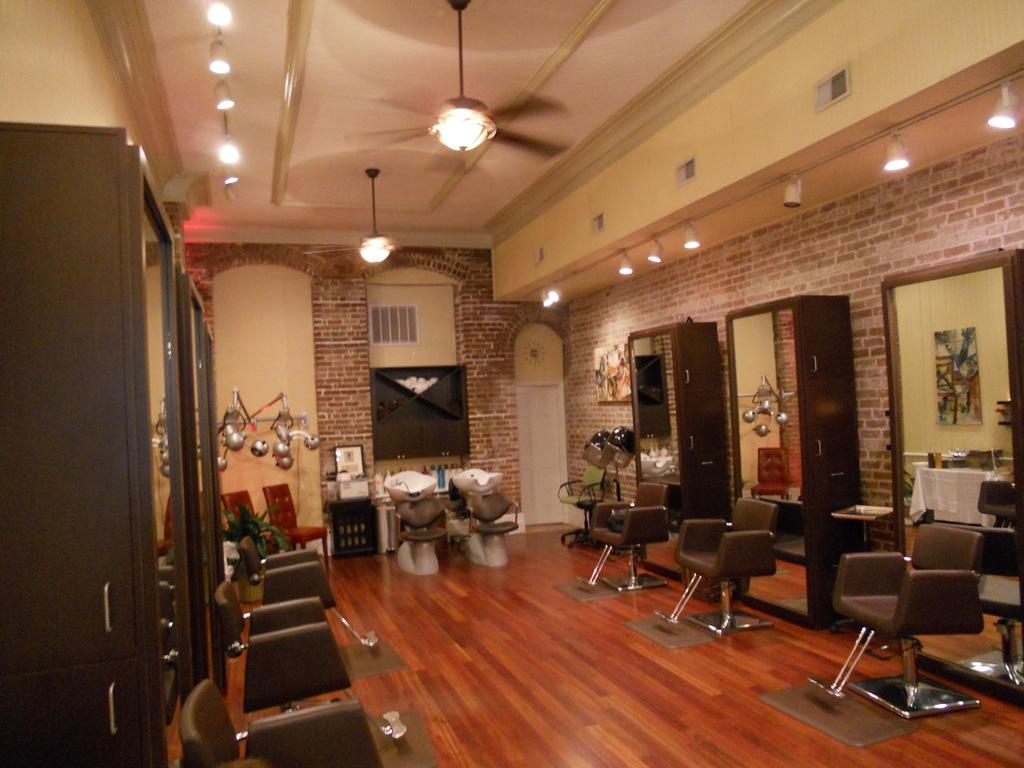What type of furniture is present in the image? There are cupboards, chairs, and mirrors in the image. What type of lighting is present in the image? There are lights in the image. What type of air circulation is present in the image? There are ceiling fans in the image. What type of objects can be seen on the left side of the image? There are objects on the left side of the image, but the specific objects are not mentioned in the facts. What type of architectural features are present in the image? There is a wall and a ceiling in the image. What type of prison is depicted in the image? There is no prison present in the image. What type of riddle can be solved by examining the objects on the left side of the image? There is no riddle present in the image, and the specific objects on the left side are not mentioned in the facts. 